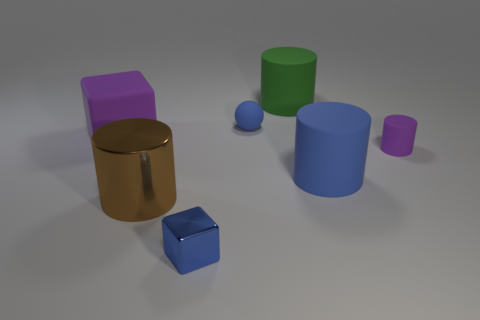What is the size of the cylinder that is the same color as the ball?
Offer a terse response. Large. There is a matte object that is the same shape as the blue metal thing; what is its size?
Give a very brief answer. Large. What number of things are either objects behind the tiny purple matte cylinder or things to the left of the big blue rubber cylinder?
Ensure brevity in your answer.  5. What size is the thing that is behind the big purple matte object and right of the matte ball?
Your answer should be compact. Large. There is a big brown metal object; is its shape the same as the purple rubber thing that is right of the metal cube?
Offer a terse response. Yes. How many things are either rubber objects that are on the left side of the small blue shiny thing or red matte cylinders?
Offer a very short reply. 1. Does the blue sphere have the same material as the small object to the right of the ball?
Ensure brevity in your answer.  Yes. There is a tiny blue thing behind the big rubber thing that is in front of the large purple matte cube; what shape is it?
Provide a short and direct response. Sphere. There is a ball; is its color the same as the block behind the brown object?
Give a very brief answer. No. Is there anything else that has the same material as the large green thing?
Offer a very short reply. Yes. 